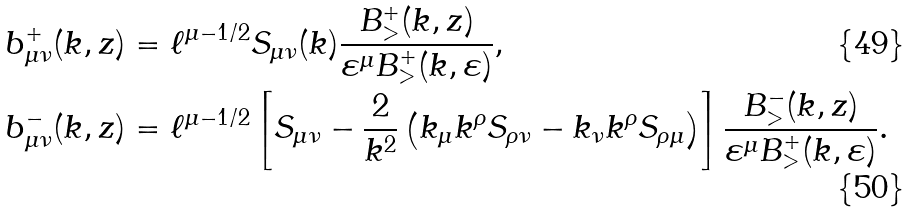<formula> <loc_0><loc_0><loc_500><loc_500>& b _ { \mu \nu } ^ { + } ( k , z ) = \ell ^ { \mu - 1 / 2 } S _ { \mu \nu } ( k ) \frac { B _ { > } ^ { + } ( k , z ) } { \varepsilon ^ { \mu } B _ { > } ^ { + } ( k , \varepsilon ) } , \\ & b _ { \mu \nu } ^ { - } ( k , z ) = \ell ^ { \mu - 1 / 2 } \left [ S _ { \mu \nu } - \frac { 2 } { k ^ { 2 } } \left ( k _ { \mu } k ^ { \rho } S _ { \rho \nu } - k _ { \nu } k ^ { \rho } S _ { \rho \mu } \right ) \right ] \frac { B _ { > } ^ { - } ( k , z ) } { \varepsilon ^ { \mu } B _ { > } ^ { + } ( k , \varepsilon ) } .</formula> 